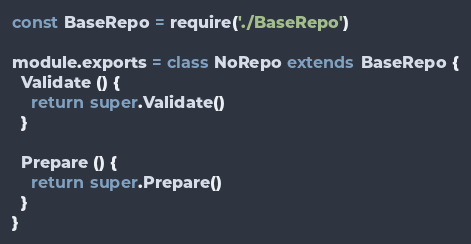<code> <loc_0><loc_0><loc_500><loc_500><_JavaScript_>const BaseRepo = require('./BaseRepo')

module.exports = class NoRepo extends BaseRepo {
  Validate () {
    return super.Validate()
  }

  Prepare () {
    return super.Prepare()
  }
}
</code> 